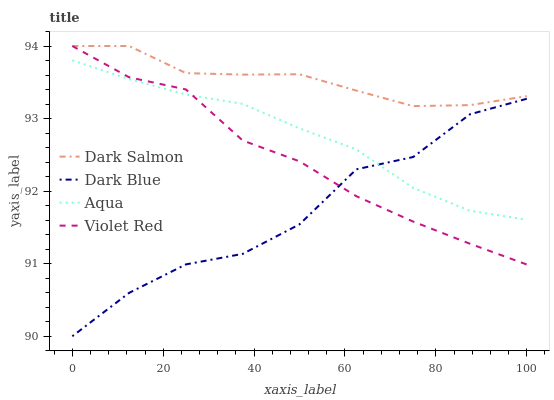Does Dark Blue have the minimum area under the curve?
Answer yes or no. Yes. Does Dark Salmon have the maximum area under the curve?
Answer yes or no. Yes. Does Violet Red have the minimum area under the curve?
Answer yes or no. No. Does Violet Red have the maximum area under the curve?
Answer yes or no. No. Is Aqua the smoothest?
Answer yes or no. Yes. Is Dark Blue the roughest?
Answer yes or no. Yes. Is Violet Red the smoothest?
Answer yes or no. No. Is Violet Red the roughest?
Answer yes or no. No. Does Dark Blue have the lowest value?
Answer yes or no. Yes. Does Violet Red have the lowest value?
Answer yes or no. No. Does Dark Salmon have the highest value?
Answer yes or no. Yes. Does Aqua have the highest value?
Answer yes or no. No. Is Aqua less than Dark Salmon?
Answer yes or no. Yes. Is Dark Salmon greater than Dark Blue?
Answer yes or no. Yes. Does Dark Salmon intersect Violet Red?
Answer yes or no. Yes. Is Dark Salmon less than Violet Red?
Answer yes or no. No. Is Dark Salmon greater than Violet Red?
Answer yes or no. No. Does Aqua intersect Dark Salmon?
Answer yes or no. No. 